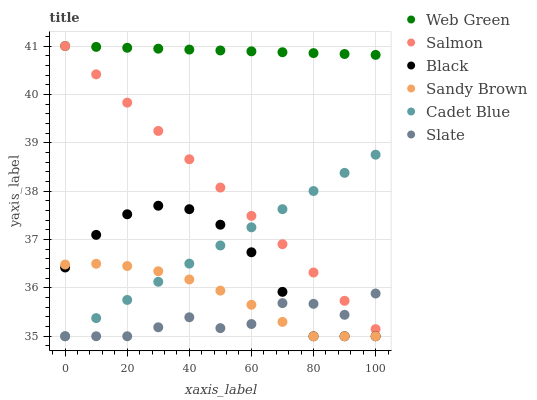Does Slate have the minimum area under the curve?
Answer yes or no. Yes. Does Web Green have the maximum area under the curve?
Answer yes or no. Yes. Does Salmon have the minimum area under the curve?
Answer yes or no. No. Does Salmon have the maximum area under the curve?
Answer yes or no. No. Is Web Green the smoothest?
Answer yes or no. Yes. Is Slate the roughest?
Answer yes or no. Yes. Is Salmon the smoothest?
Answer yes or no. No. Is Salmon the roughest?
Answer yes or no. No. Does Cadet Blue have the lowest value?
Answer yes or no. Yes. Does Salmon have the lowest value?
Answer yes or no. No. Does Web Green have the highest value?
Answer yes or no. Yes. Does Slate have the highest value?
Answer yes or no. No. Is Black less than Salmon?
Answer yes or no. Yes. Is Web Green greater than Black?
Answer yes or no. Yes. Does Cadet Blue intersect Black?
Answer yes or no. Yes. Is Cadet Blue less than Black?
Answer yes or no. No. Is Cadet Blue greater than Black?
Answer yes or no. No. Does Black intersect Salmon?
Answer yes or no. No. 